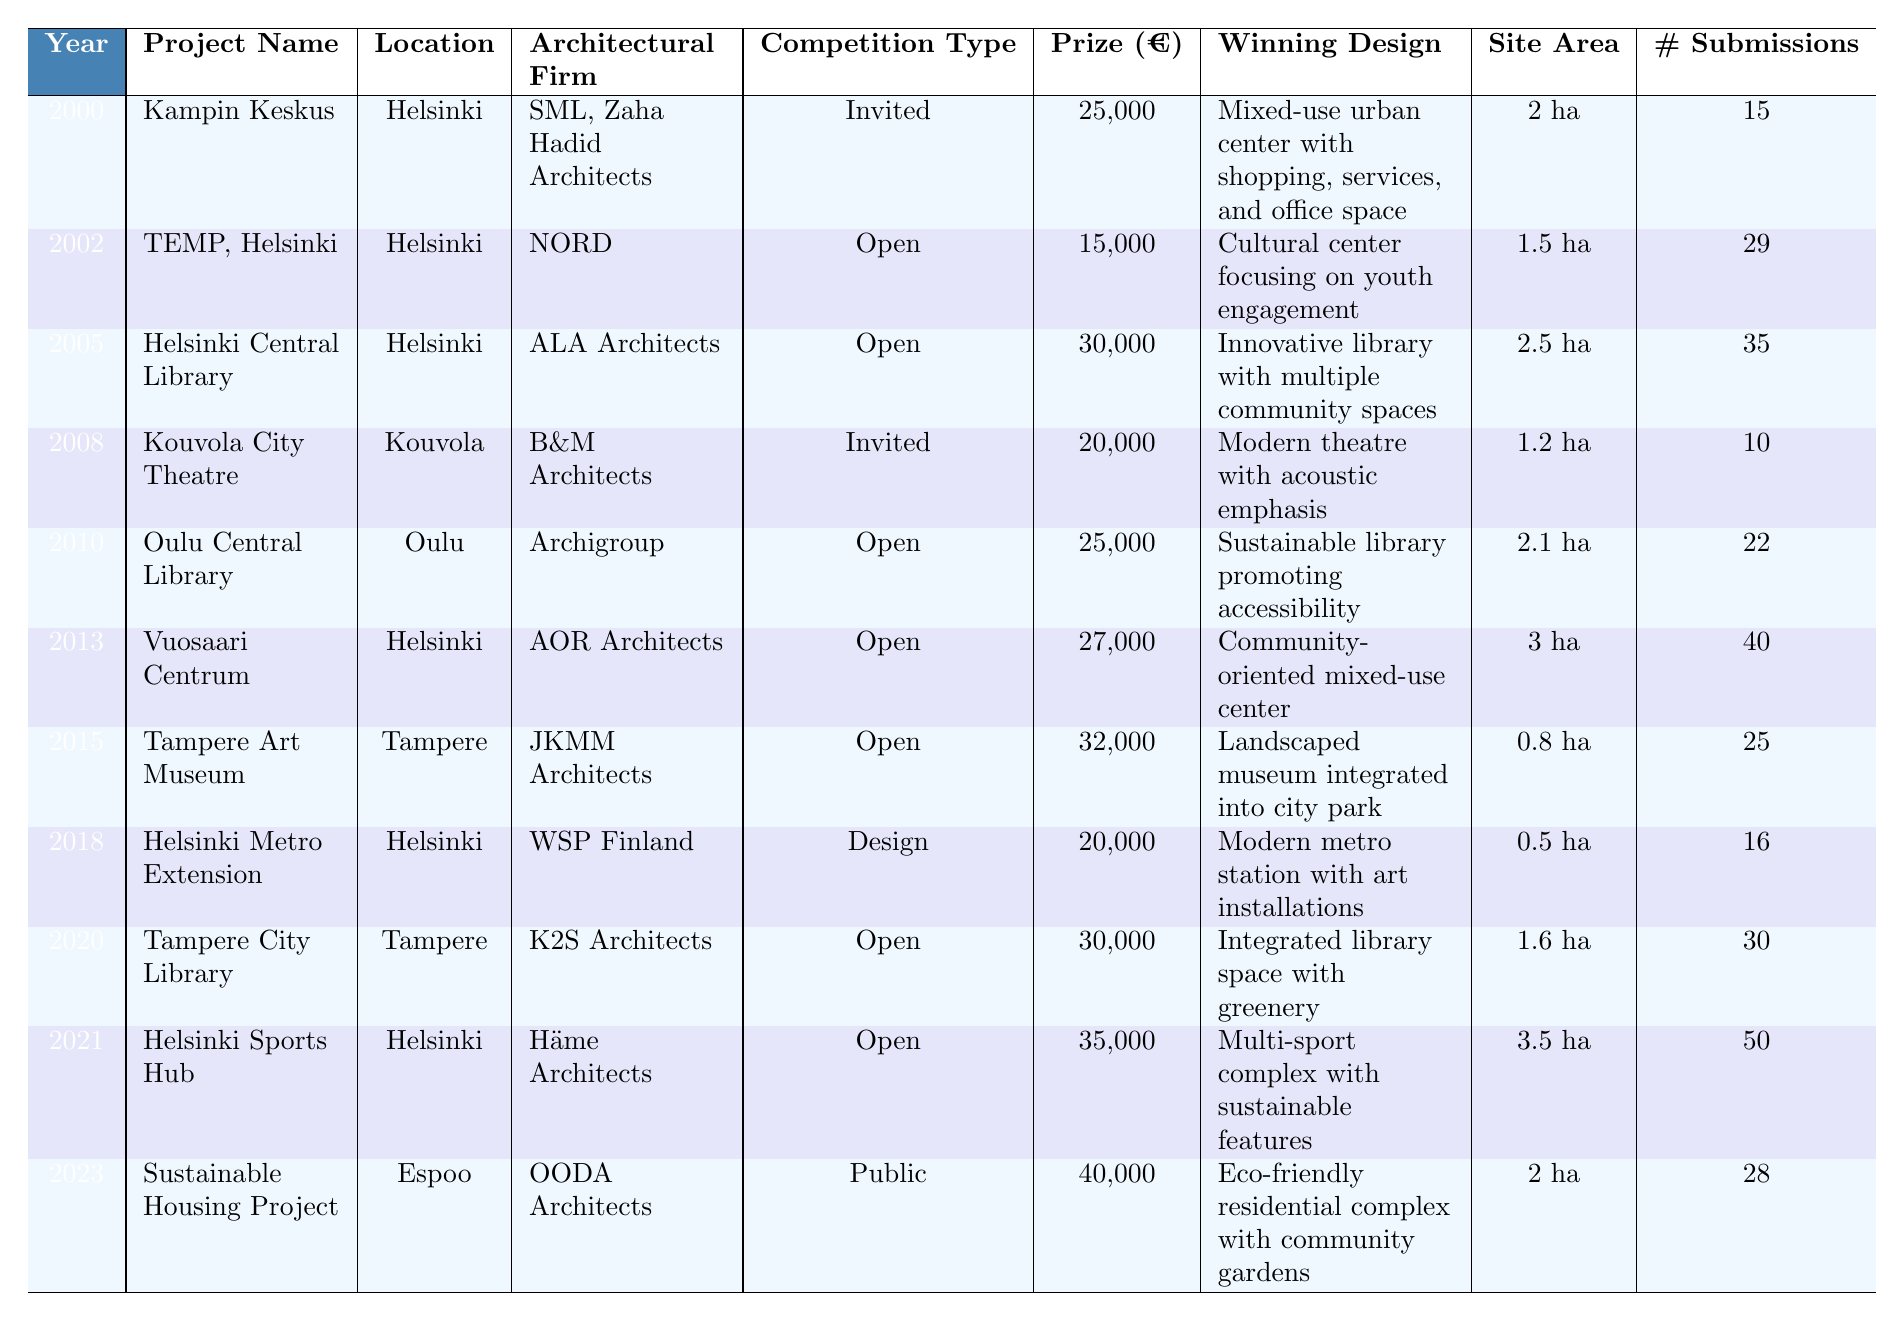What is the prize amount for the Helsinki Central Library competition? The table shows that the prize amount for the Helsinki Central Library, held in 2005, is 30,000 euros.
Answer: 30,000 euros How many submissions were received for the Tampere Art Museum competition? According to the table, the Tampere Art Museum competition in 2015 received 25 submissions.
Answer: 25 submissions Which architectural firm designed the Helsinki Sports Hub? The table indicates that Häme Architects designed the Helsinki Sports Hub, which took place in 2021.
Answer: Häme Architects What was the winning design for the Sustainable Housing Project? The table specifies that the winning design for the Sustainable Housing Project is an eco-friendly residential complex with community gardens.
Answer: Eco-friendly residential complex with community gardens In which city was the Kouvola City Theatre project located? The table clearly states that the Kouvola City Theatre project is located in Kouvola.
Answer: Kouvola What is the site area of the Vuosaari Centrum? The Vuosaari Centrum, as per the table, has a site area of 3 hectares.
Answer: 3 hectares What is the competition type for the Helsinki Metro Extension? Based on the table, the Helsinki Metro Extension competition is classified as a design competition.
Answer: Design competition What is the average prize amount of the open competitions listed in the table? The open competitions listed are for TEMP (15,000), Helsinki Central Library (30,000), Oulu Central Library (25,000), Vuosaari Centrum (27,000), Tampere City Library (30,000), and Helsinki Sports Hub (35,000). Their total is 15,000 + 30,000 + 25,000 + 27,000 + 30,000 + 35,000 = 162,000. There are 6 open competitions, so the average prize amount is 162,000 / 6 = 27,000 euros.
Answer: 27,000 euros Was there a competition for a cultural center in Helsinki? Yes, the table confirms that there was a competition for TEMP, Helsinki, which was a cultural center focusing on youth engagement.
Answer: Yes How many more submissions did the Helsinki Sports Hub receive compared to the Kouvola City Theatre? The Helsinki Sports Hub received 50 submissions and the Kouvola City Theatre had 10 submissions. The difference is 50 - 10 = 40.
Answer: 40 more submissions What is the prize amount of the project with the maximum number of submissions? The project with the maximum number of submissions is the Helsinki Sports Hub with 50 submissions, and it has a prize amount of 35,000 euros.
Answer: 35,000 euros Which architectural firm had the highest prize amount competition? The Sustainable Housing Project, designed by OODA Architects in 2023, has the highest prize amount of 40,000 euros, compared to other listed firms.
Answer: OODA Architects 